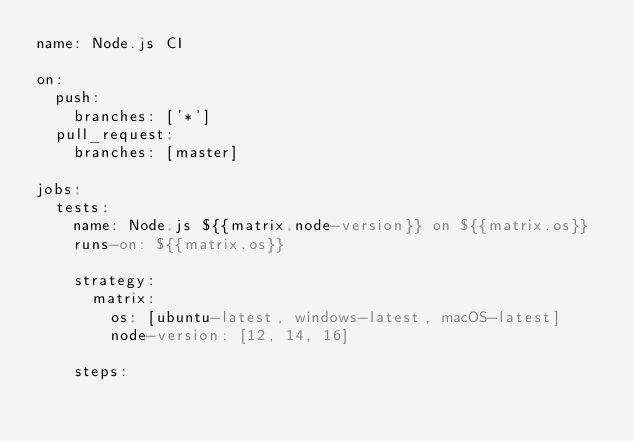Convert code to text. <code><loc_0><loc_0><loc_500><loc_500><_YAML_>name: Node.js CI

on:
  push:
    branches: ['*']
  pull_request:
    branches: [master]

jobs:
  tests:
    name: Node.js ${{matrix.node-version}} on ${{matrix.os}}
    runs-on: ${{matrix.os}}

    strategy:
      matrix:
        os: [ubuntu-latest, windows-latest, macOS-latest]
        node-version: [12, 14, 16]

    steps:</code> 